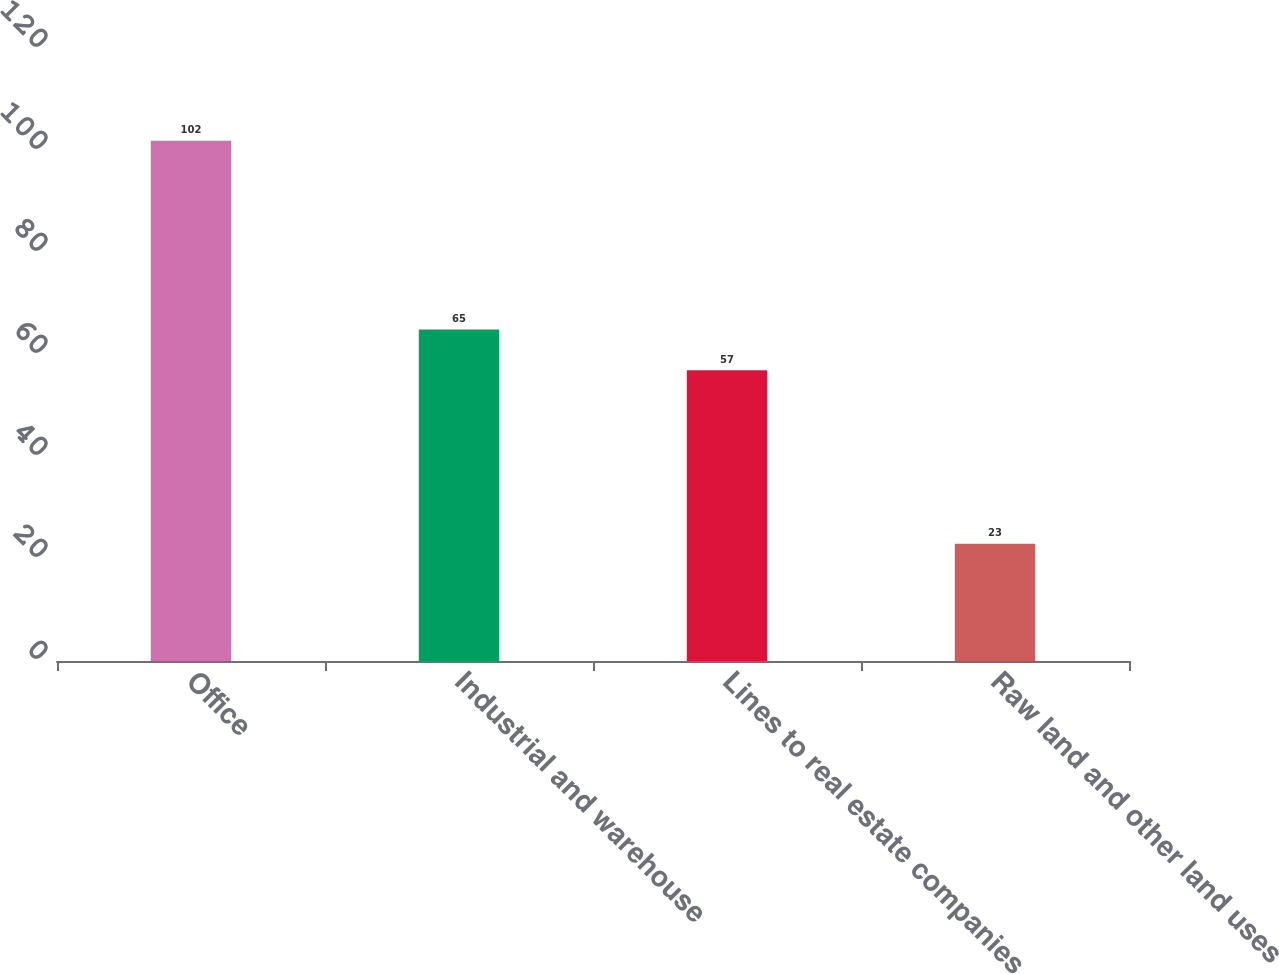Convert chart. <chart><loc_0><loc_0><loc_500><loc_500><bar_chart><fcel>Office<fcel>Industrial and warehouse<fcel>Lines to real estate companies<fcel>Raw land and other land uses<nl><fcel>102<fcel>65<fcel>57<fcel>23<nl></chart> 